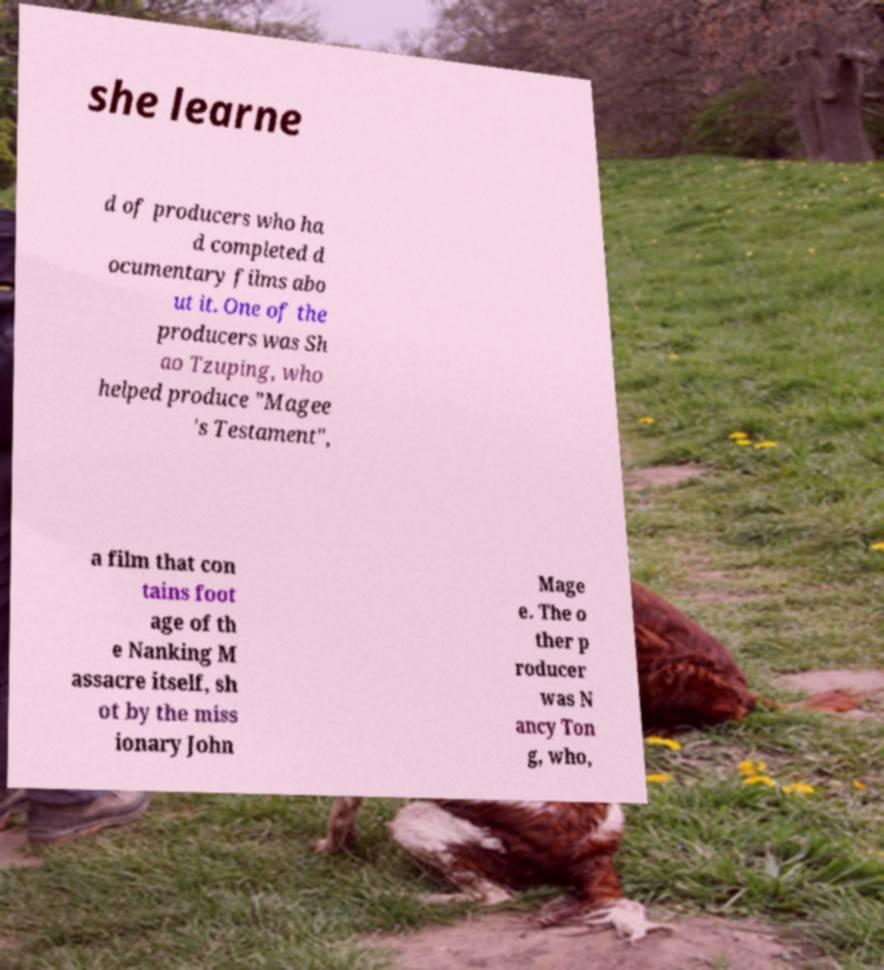Could you assist in decoding the text presented in this image and type it out clearly? she learne d of producers who ha d completed d ocumentary films abo ut it. One of the producers was Sh ao Tzuping, who helped produce "Magee 's Testament", a film that con tains foot age of th e Nanking M assacre itself, sh ot by the miss ionary John Mage e. The o ther p roducer was N ancy Ton g, who, 